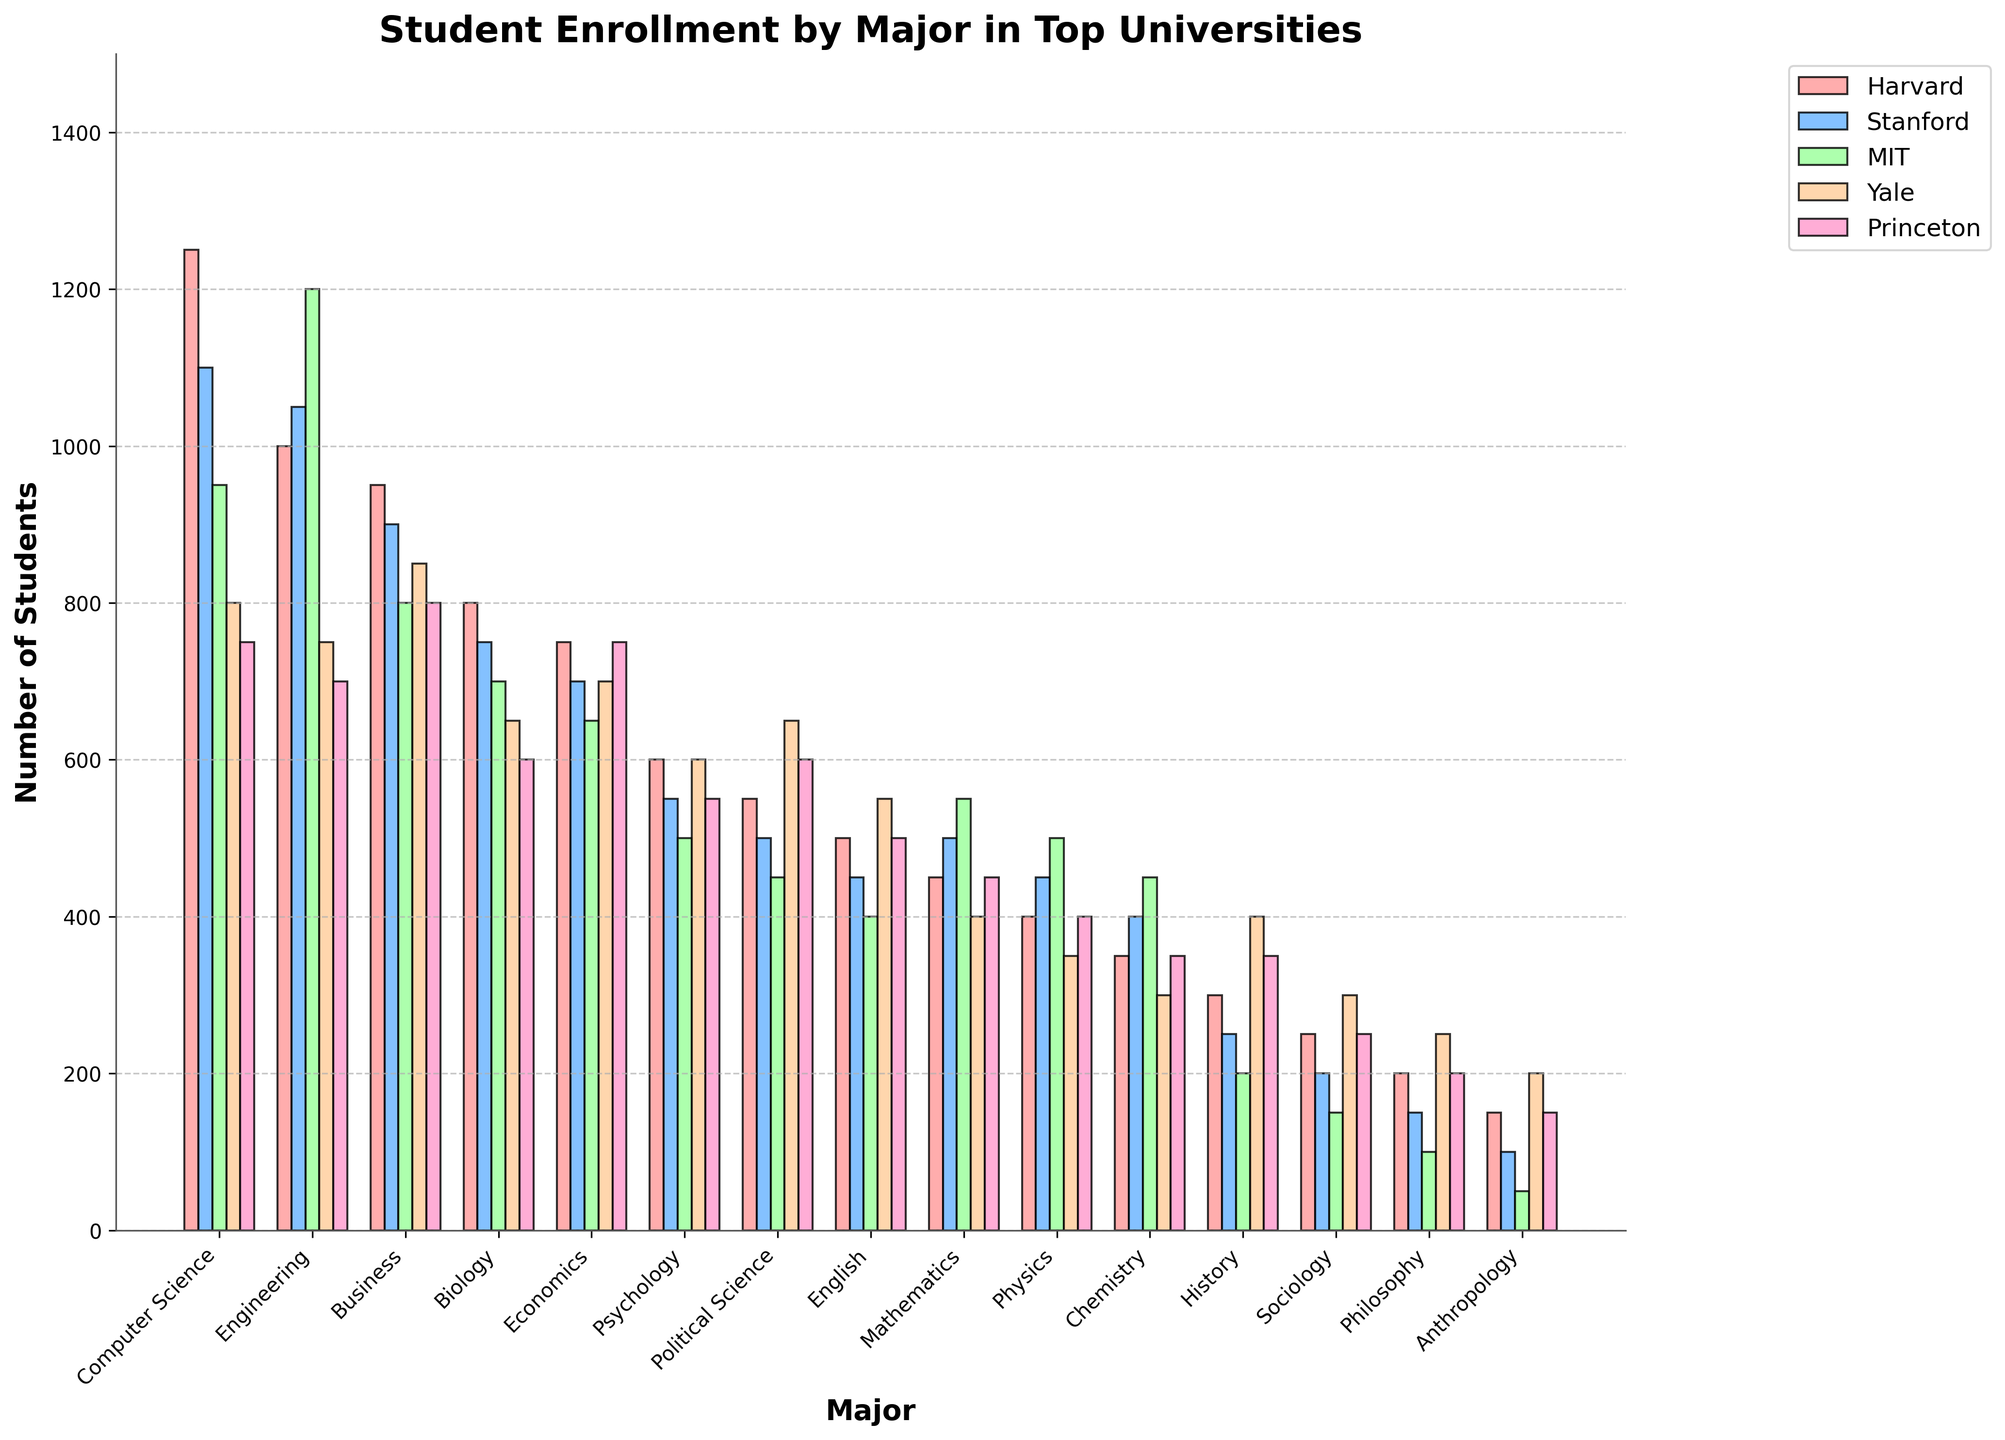Which major has the highest enrollment at Harvard? Look at the height of the bars for Harvard and identify the tallest one, which indicates the major with the highest enrollment.
Answer: Computer Science Which university has the highest enrollment in Engineering? Compare the height of the bars representing Engineering across all universities and find the tallest one, indicating which university has the highest enrollment.
Answer: MIT What is the total enrollment for Political Science at Yale and Princeton? Sum the values of Political Science at Yale (650) and Princeton (600). So, 650 + 600 = 1250.
Answer: 1250 Compare the enrollment in Business between Stanford and Princeton. Which university has more students enrolled, and by how many? Examine the heights of the Business bars for both universities. Stanford has 900 students, and Princeton has 800 students, so the difference is 900 - 800 = 100.
Answer: Stanford, by 100 Which major has the lowest enrollment at Stanford? Identify the shortest bar for Stanford, which represents the major with the lowest enrollment.
Answer: Anthropology How many more students are enrolled in Computer Science than Economics at MIT? Subtract the enrollment in Economics (650) from that in Computer Science (950). So, 950 - 650 = 300.
Answer: 300 Rank the universities based on total enrollment in Biology from highest to lowest. Add up the enrollment numbers in Biology for each university and rank them. Harvard has the highest (800), followed by Stanford (750), MIT (700), Yale (650), and Princeton (600).
Answer: Harvard > Stanford > MIT > Yale > Princeton What is the average enrollment in Mathematics across all universities? Sum the enrollment numbers for Mathematics across all universities and then divide by the number of universities (450+500+550+400+450)/5.
Answer: 470 Which university has the second highest enrollment in Computer Science? Find the bar heights for Computer Science for all universities and identify the second tallest one. The second highest after Harvard (1250) is Stanford (1100).
Answer: Stanford Between English and Chemistry at Yale, which major has more students and by how much? Compare the enrollment figures of English (550) and Chemistry (300) at Yale. The difference is 550 - 300 = 250.
Answer: English, by 250 